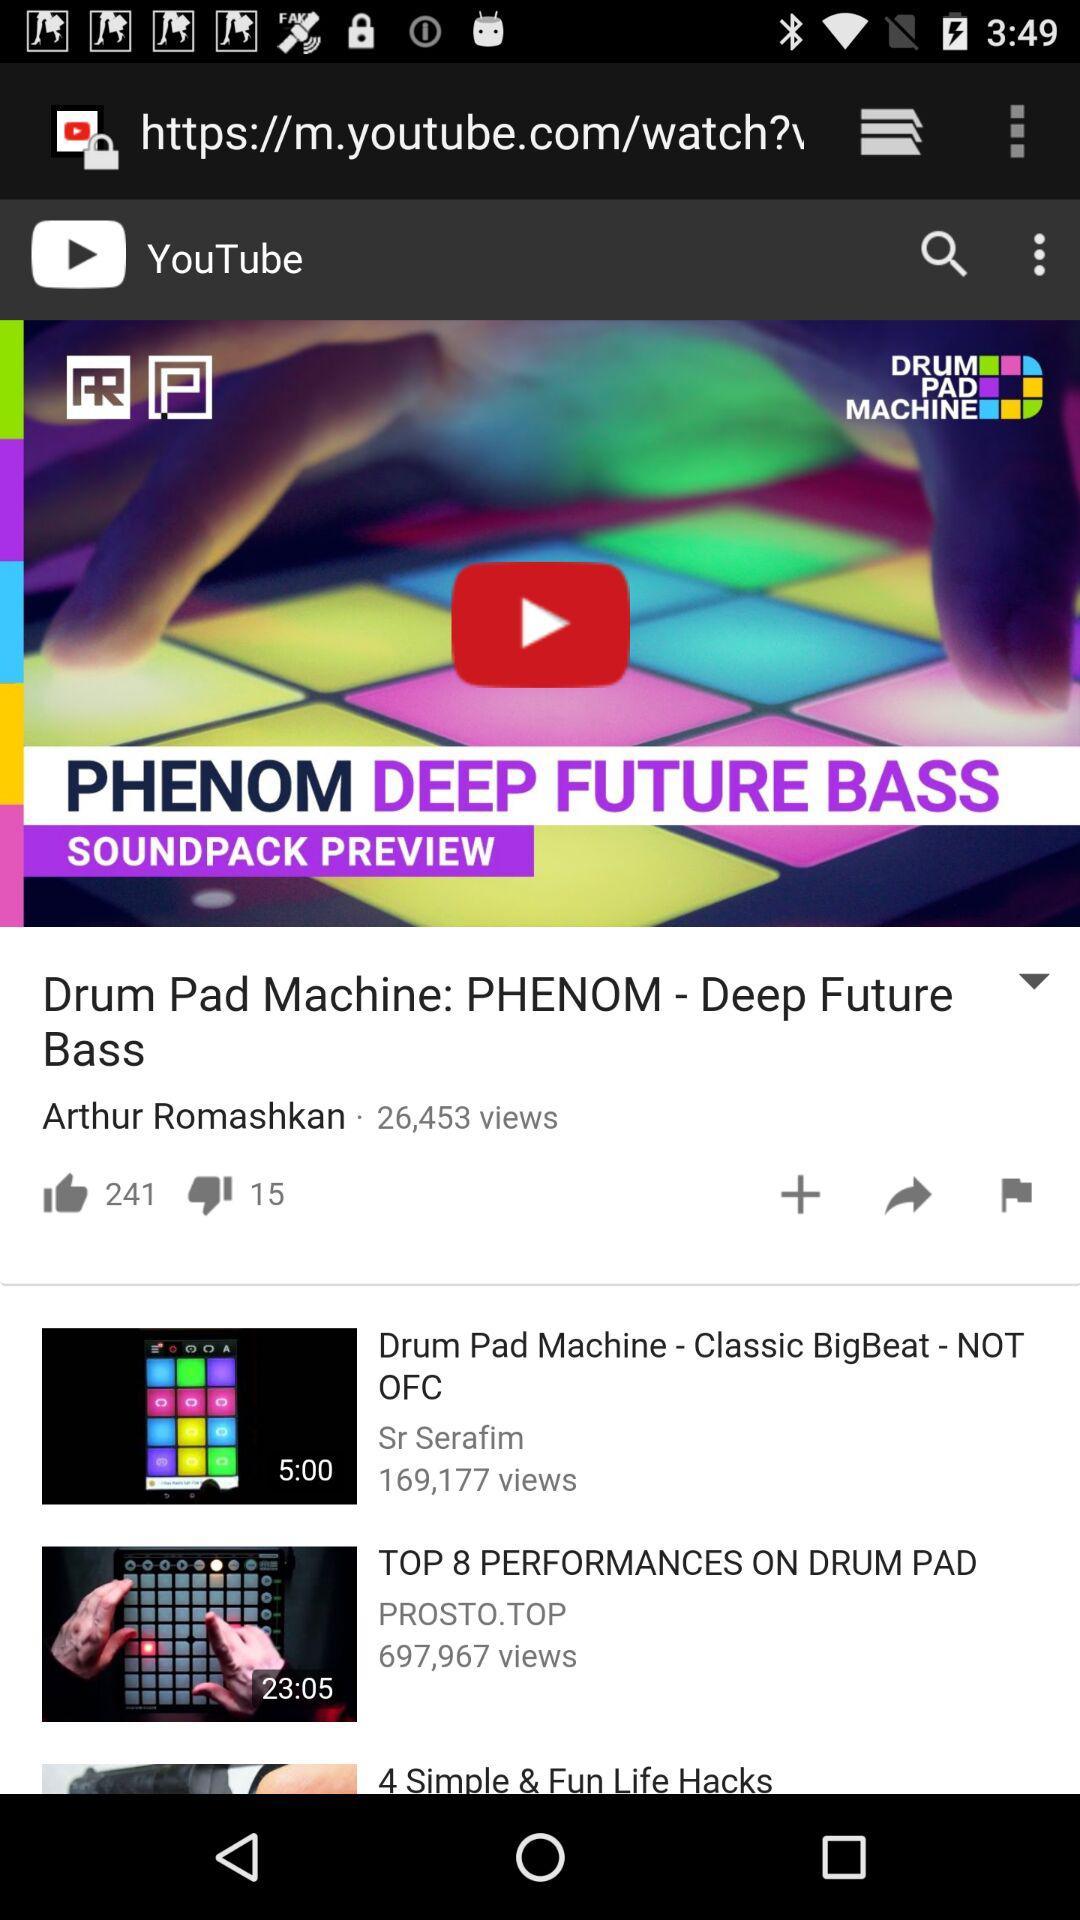How many people have disliked "Drum Pad Machine: PHENOM - Deep Future Bass"? It is disliked by 15 people. 